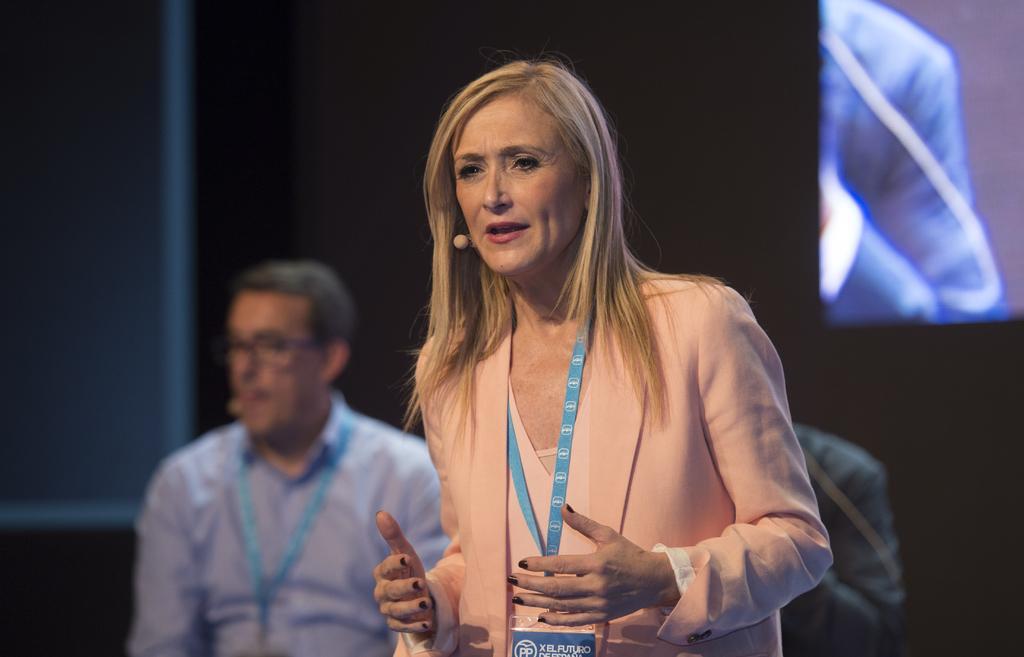In one or two sentences, can you explain what this image depicts? In the center of the image three persons are standing. In the background of the image we can see wall, screen are there. 